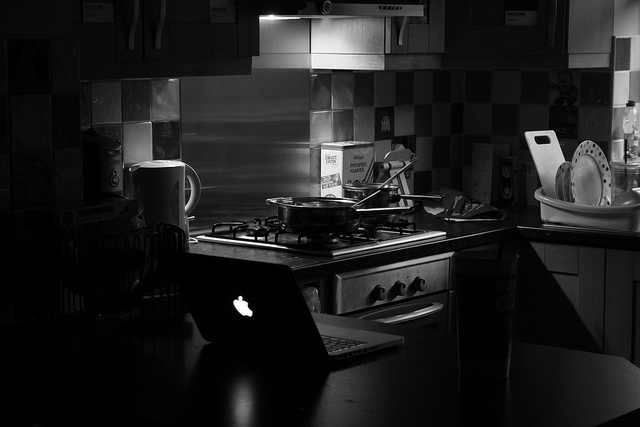Describe the objects in this image and their specific colors. I can see oven in black, gray, darkgray, and lightgray tones, laptop in black, gray, white, and darkgray tones, chair in black and gray tones, cup in black, gray, darkgray, and lightgray tones, and cup in black, gray, darkgray, and lightgray tones in this image. 